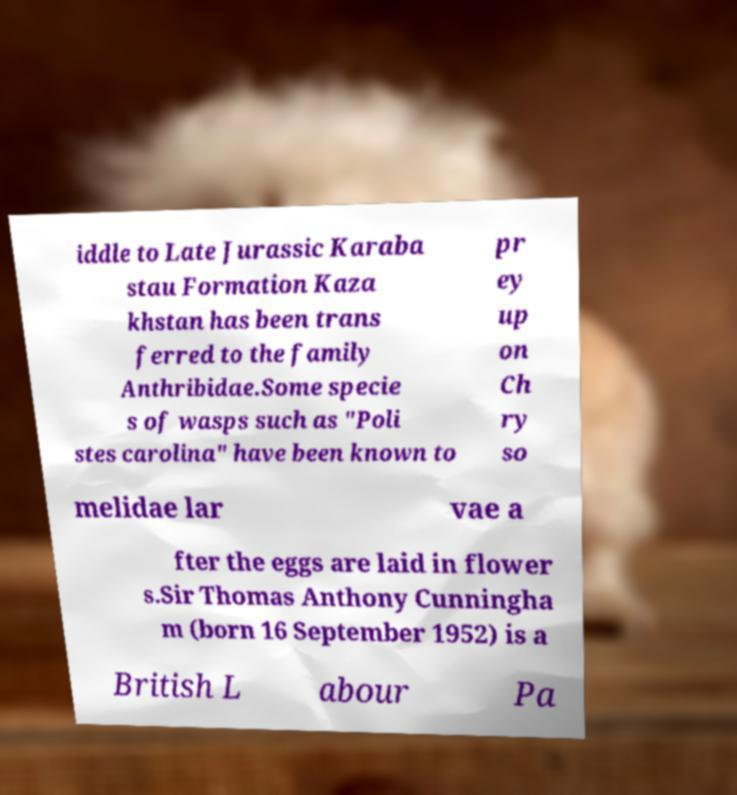Please identify and transcribe the text found in this image. iddle to Late Jurassic Karaba stau Formation Kaza khstan has been trans ferred to the family Anthribidae.Some specie s of wasps such as "Poli stes carolina" have been known to pr ey up on Ch ry so melidae lar vae a fter the eggs are laid in flower s.Sir Thomas Anthony Cunningha m (born 16 September 1952) is a British L abour Pa 